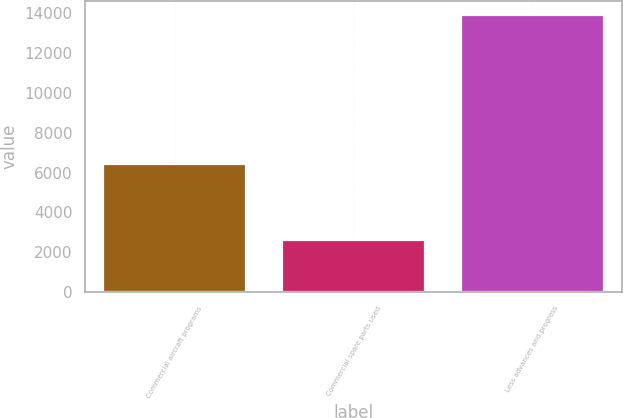<chart> <loc_0><loc_0><loc_500><loc_500><bar_chart><fcel>Commercial aircraft programs<fcel>Commercial spare parts used<fcel>Less advances and progress<nl><fcel>6448<fcel>2596<fcel>13934<nl></chart> 